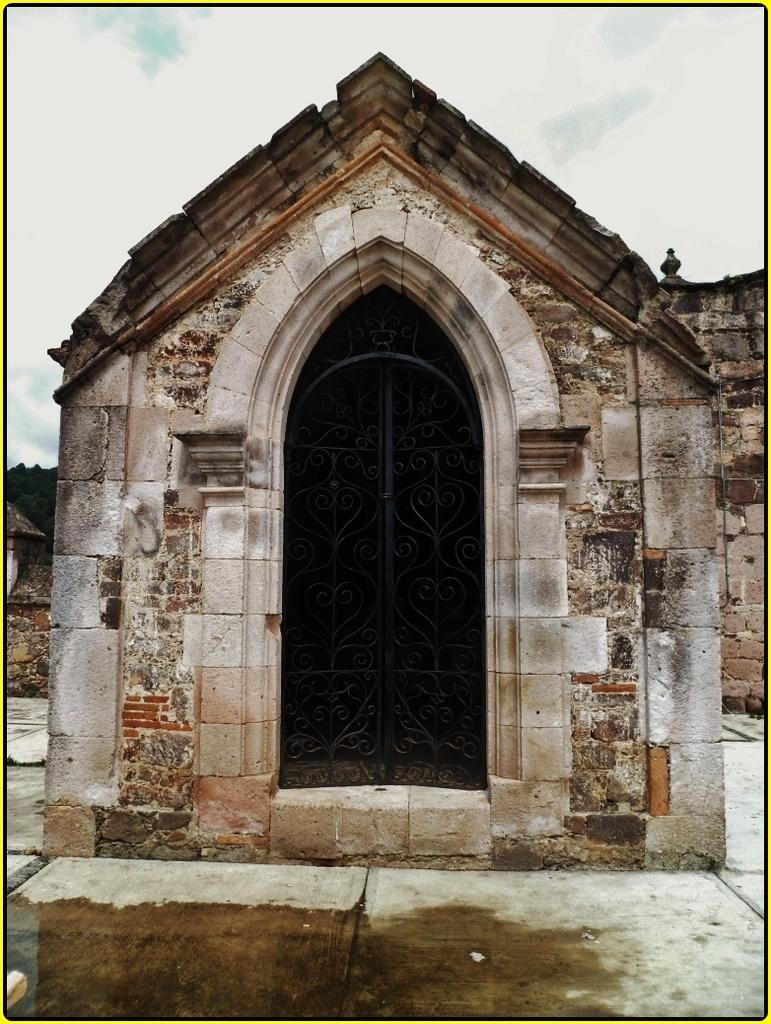Please provide a concise description of this image. In this image we can see a small room, doors and water on the floor. In the background we can see wall, trees and clouds in the sky. 